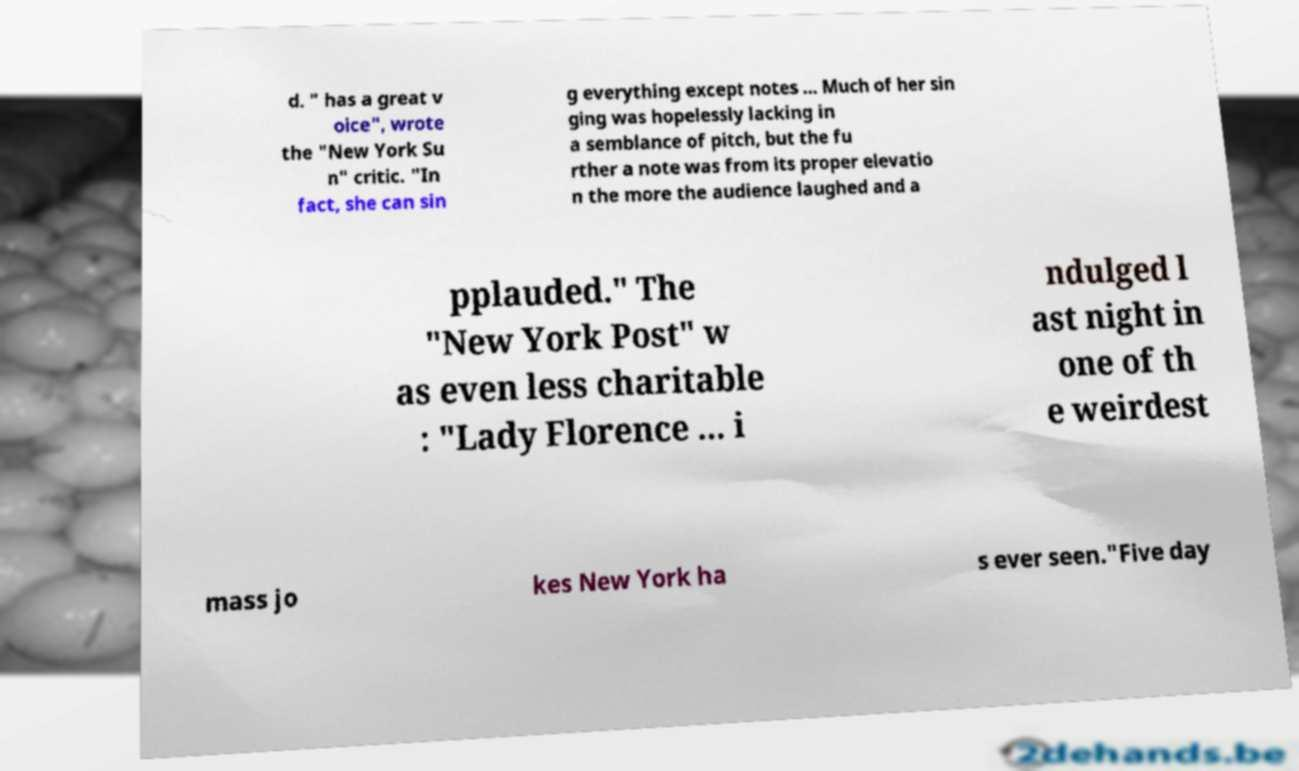Please identify and transcribe the text found in this image. d. " has a great v oice", wrote the "New York Su n" critic. "In fact, she can sin g everything except notes ... Much of her sin ging was hopelessly lacking in a semblance of pitch, but the fu rther a note was from its proper elevatio n the more the audience laughed and a pplauded." The "New York Post" w as even less charitable : "Lady Florence ... i ndulged l ast night in one of th e weirdest mass jo kes New York ha s ever seen."Five day 